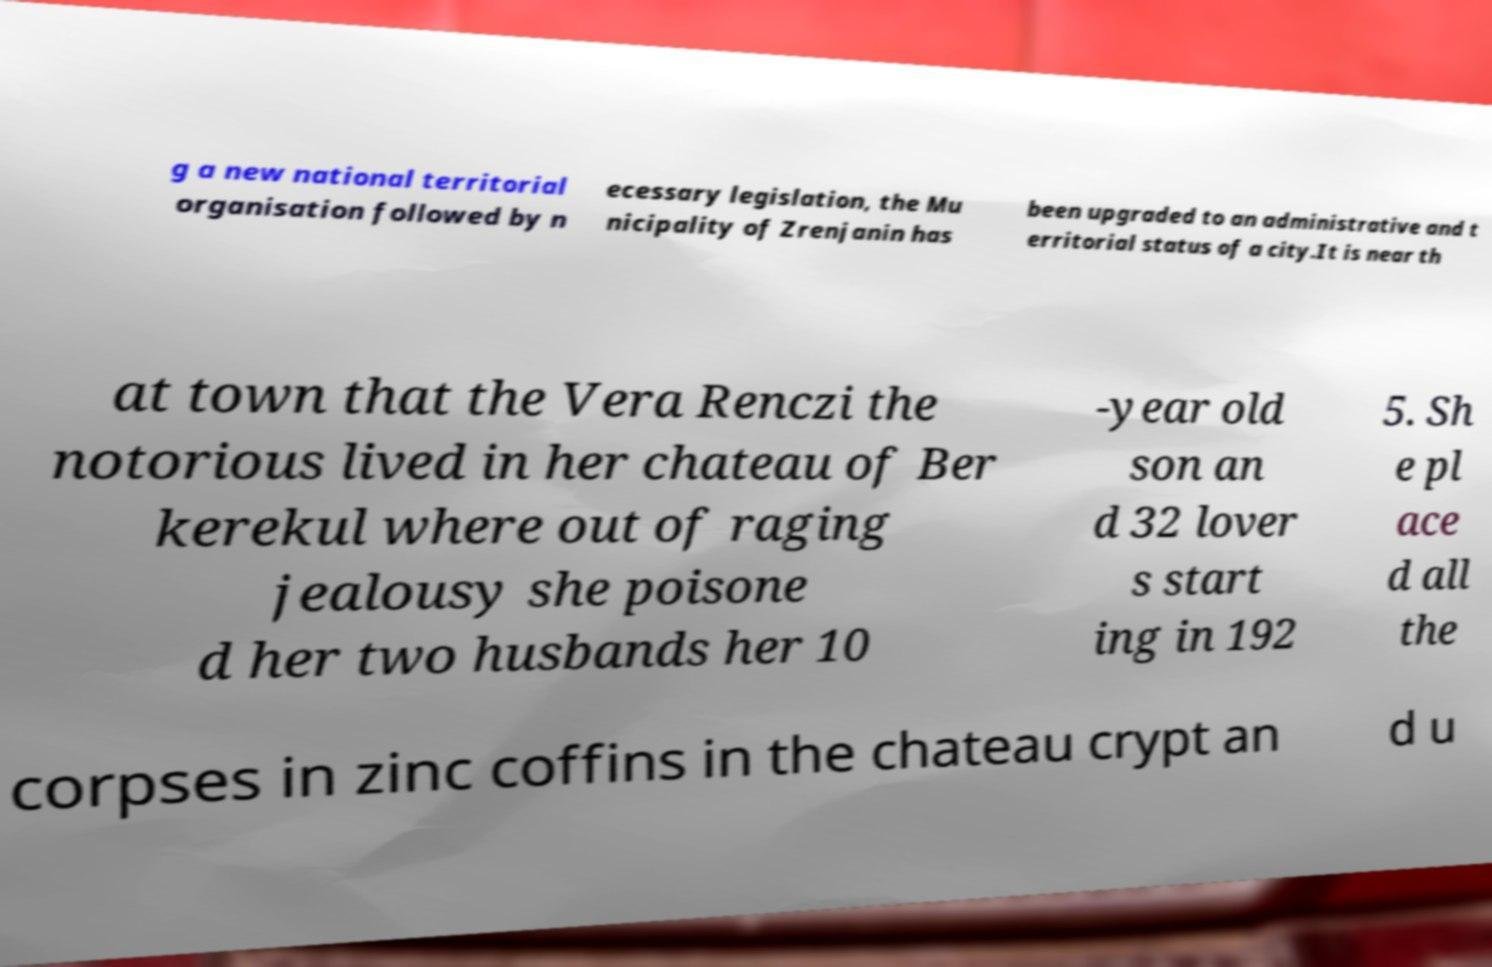Please identify and transcribe the text found in this image. g a new national territorial organisation followed by n ecessary legislation, the Mu nicipality of Zrenjanin has been upgraded to an administrative and t erritorial status of a city.It is near th at town that the Vera Renczi the notorious lived in her chateau of Ber kerekul where out of raging jealousy she poisone d her two husbands her 10 -year old son an d 32 lover s start ing in 192 5. Sh e pl ace d all the corpses in zinc coffins in the chateau crypt an d u 